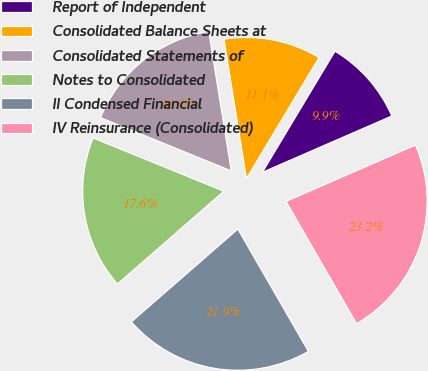Convert chart. <chart><loc_0><loc_0><loc_500><loc_500><pie_chart><fcel>Report of Independent<fcel>Consolidated Balance Sheets at<fcel>Consolidated Statements of<fcel>Notes to Consolidated<fcel>II Condensed Financial<fcel>IV Reinsurance (Consolidated)<nl><fcel>9.87%<fcel>11.15%<fcel>16.29%<fcel>17.57%<fcel>21.92%<fcel>23.2%<nl></chart> 